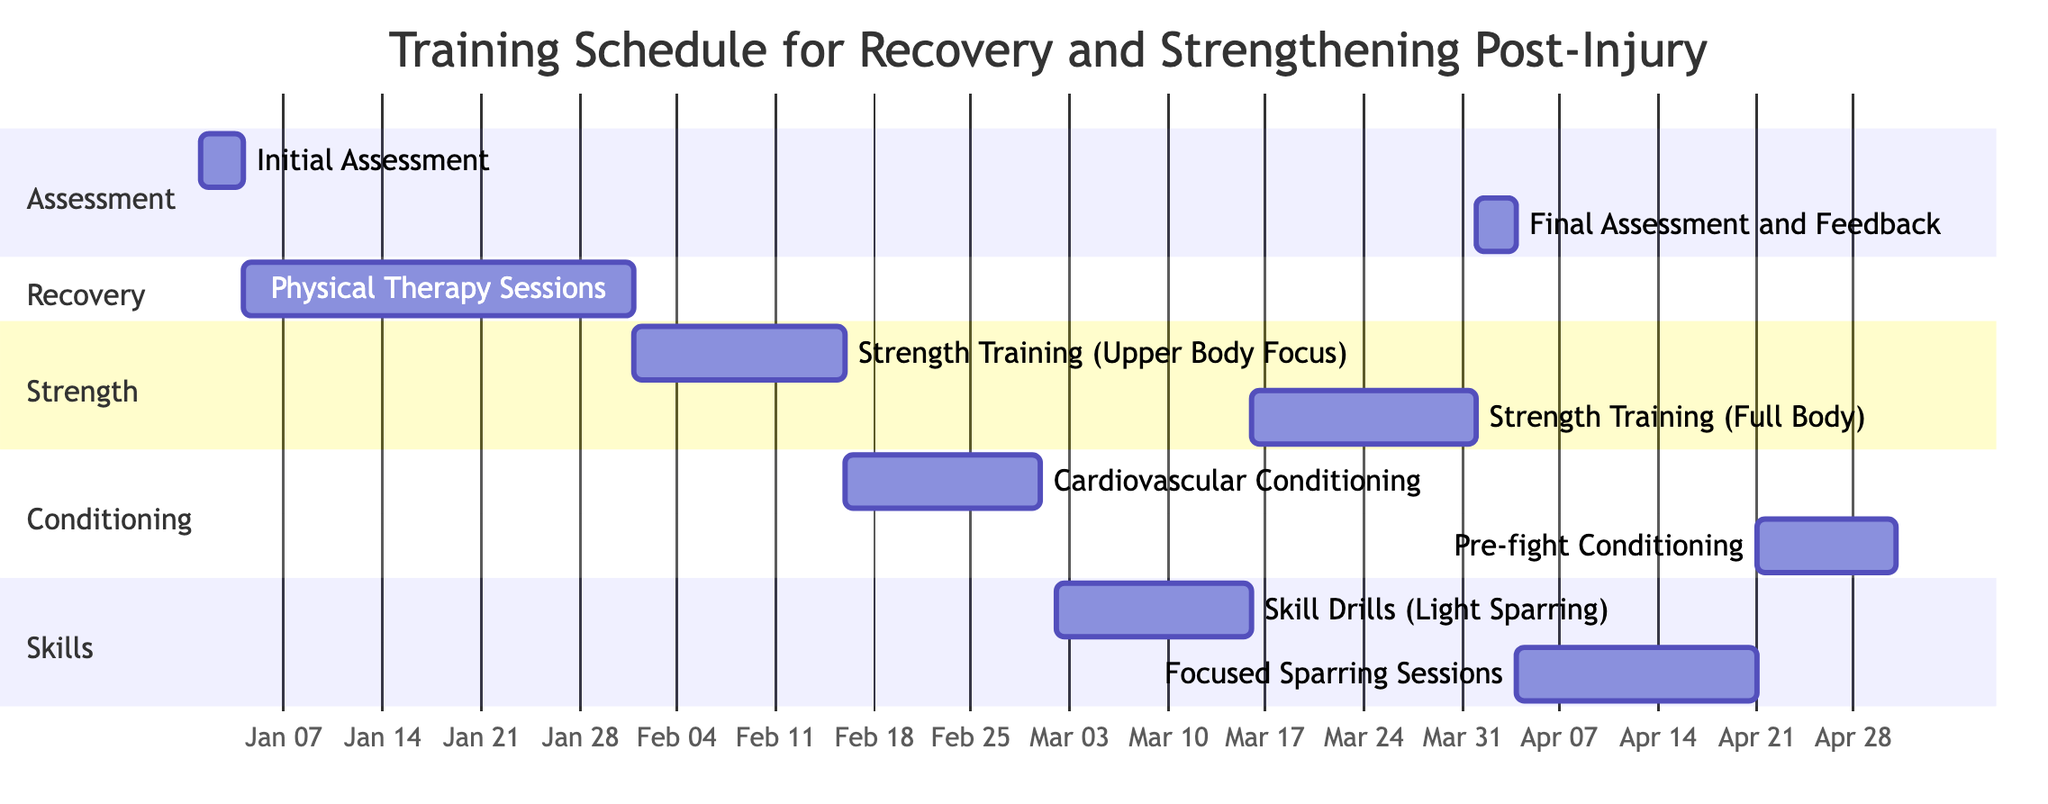What is the duration of the Physical Therapy Sessions? The Physical Therapy Sessions task spans from January 4, 2024, to January 31, 2024. By calculating the number of days between these two dates (28 days), we determine the task's duration.
Answer: 28 days What is the start date of the Strength Training (Full Body) task? The Strength Training (Full Body) task is indicated in the Gantt Chart with a start date of March 16, 2024. This specific detail is directly derived from the diagram.
Answer: March 16, 2024 How many days are allocated for Skill Drills (Light Sparring)? The Skill Drills (Light Sparring) task is scheduled for 14 days, starting from March 2, 2024, and ending on March 15, 2024. This duration is clearly indicated next to the task in the chart.
Answer: 14 days Which task immediately follows Cardiovascular Conditioning in the timeline? The Cardiovascular Conditioning task ends on March 1, 2024. The task that immediately follows it is Skill Drills (Light Sparring), which starts on March 2, 2024.
Answer: Skill Drills (Light Sparring) What is the total number of sections represented in the Gantt Chart? The Gantt Chart includes four distinct sections: Assessment, Recovery, Strength, Conditioning, and Skills. To find the total, we simply count the sections listed in the diagram.
Answer: 5 sections What is the last task in the training schedule? According to the Gantt Chart, the last task is Pre-fight Conditioning, which starts on April 21, 2024, and ends on April 30, 2024. This information is derived directly from the task list in the Gantt Chart.
Answer: Pre-fight Conditioning How many days are scheduled for Focused Sparring Sessions? The Focused Sparring Sessions are scheduled for 17 days, starting on April 4, 2024, and ending on April 20, 2024. The duration is explicitly stated next to the task in the diagram.
Answer: 17 days Which section does the Final Assessment and Feedback task belong to? The Final Assessment and Feedback task is categorized under the Assessment section, as indicated in the Gantt Chart. This can be determined by its placement within the sections labeled in the diagram.
Answer: Assessment 